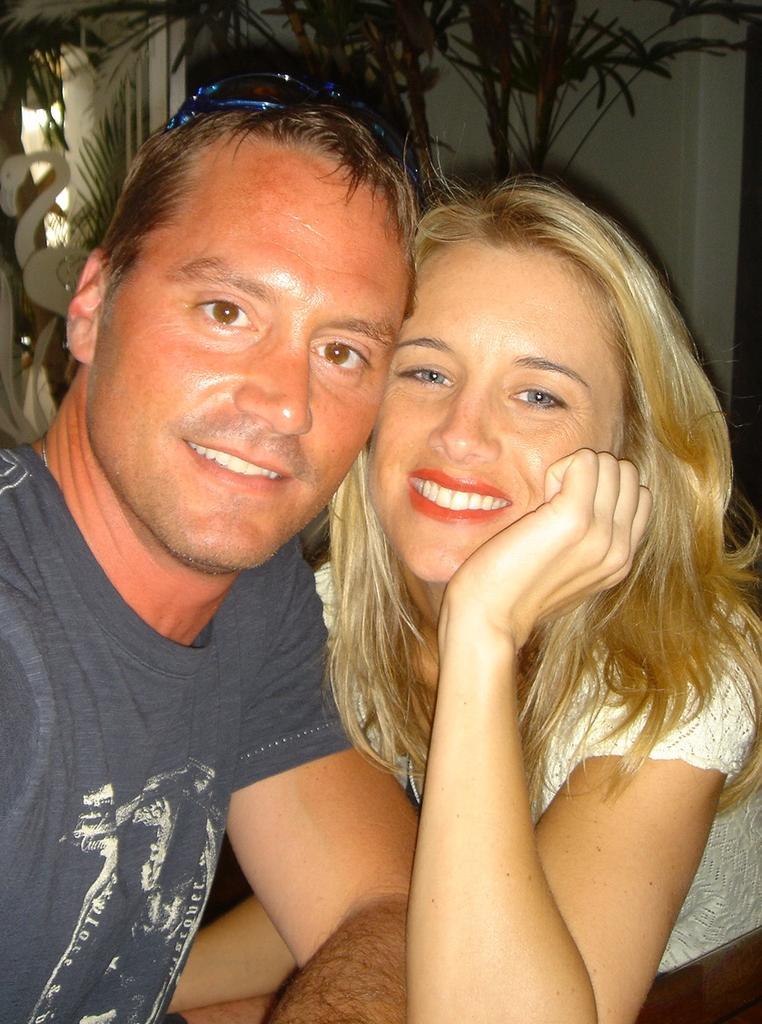Could you give a brief overview of what you see in this image? In this image we can a man and a woman, where man is wearing a round neck t shirt and woman is in white top. In the background we can see white wall and plants. We can also see they both are smiling. 